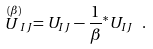<formula> <loc_0><loc_0><loc_500><loc_500>\stackrel { ( \beta ) } { U } _ { I J } = U _ { I J } - \frac { 1 } { \beta } { ^ { * } U _ { I J } } \ .</formula> 